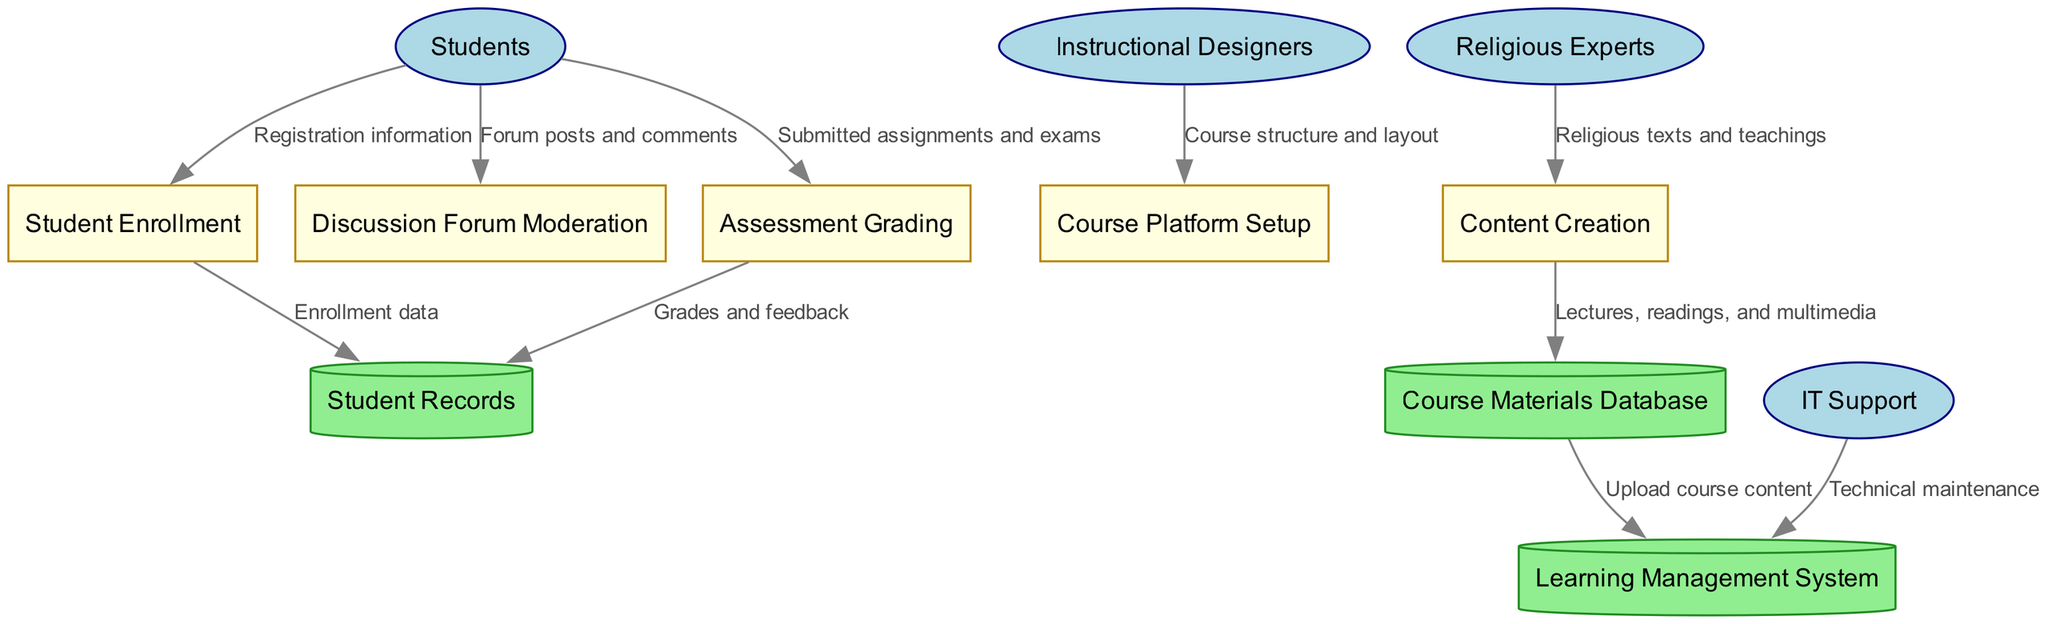What are the external entities in this diagram? The diagram shows four external entities: Students, Instructional Designers, Religious Experts, and IT Support. These external entities are represented by ellipses.
Answer: Students, Instructional Designers, Religious Experts, IT Support How many processes are in the diagram? There are five processes indicated by rectangular nodes: Content Creation, Course Platform Setup, Student Enrollment, Discussion Forum Moderation, and Assessment Grading. Counting these gives a total of five.
Answer: 5 Which external entity provides religious texts and teachings? The flow from "Religious Experts" to "Content Creation" indicates that religious texts and teachings are provided by Religious Experts.
Answer: Religious Experts What type of data flow is from "Students" to "Assessment Grading"? The data flow from "Students" to "Assessment Grading" carries submitted assignments and exams. Therefore, it can be classified as assignment data flow.
Answer: Submitted assignments and exams Which data store receives grades and feedback from the Assessment Grading process? The flow from "Assessment Grading" to "Student Records" shows that grades and feedback are recorded in the Student Records data store.
Answer: Student Records How does the Course Materials Database provide content? The flow from "Course Materials Database" to "Learning Management System" indicates that it is used to upload course content, including lectures and multimedia materials.
Answer: Upload course content What role does the IT Support entity play in relation to the Learning Management System? The IT Support entity is responsible for technical maintenance of the Learning Management System, as indicated by the directed flow from IT Support to Learning Management System.
Answer: Technical maintenance Where does student enrollment data go after being processed? The flow from "Student Enrollment" to "Student Records" indicates that enrollment data is sent to Student Records.
Answer: Student Records What is the purpose of the Discussion Forum Moderation process? The process labelled Discussion Forum Moderation handles forum posts and comments submitted by students as part of course engagement and discussion facilitation.
Answer: Forum posts and comments 